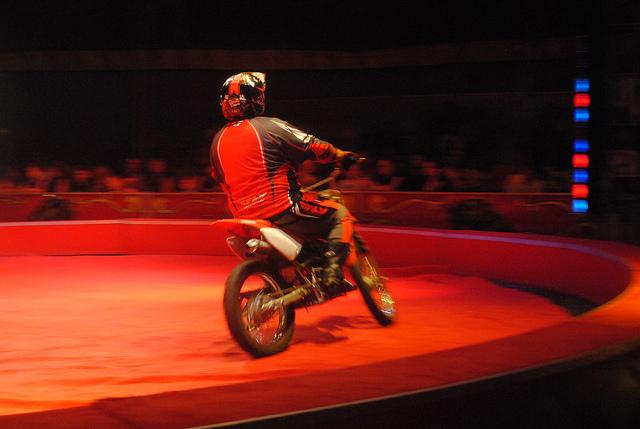Which direction is the motorcycle headed in this scene?
Keep it brief. Left. What color is the motorists shirt?
Give a very brief answer. Red. Is there an audience?
Concise answer only. Yes. 